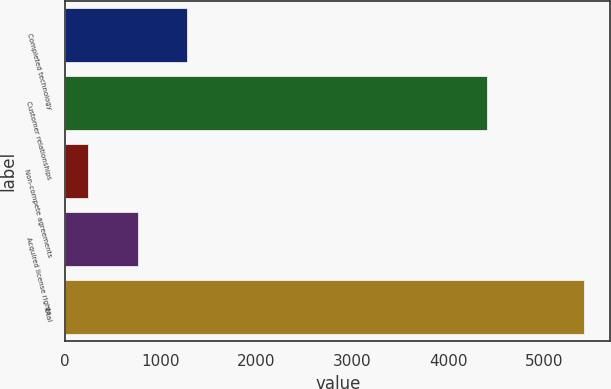<chart> <loc_0><loc_0><loc_500><loc_500><bar_chart><fcel>Completed technology<fcel>Customer relationships<fcel>Non-compete agreements<fcel>Acquired license rights<fcel>Total<nl><fcel>1277.4<fcel>4404<fcel>241<fcel>759.2<fcel>5423<nl></chart> 